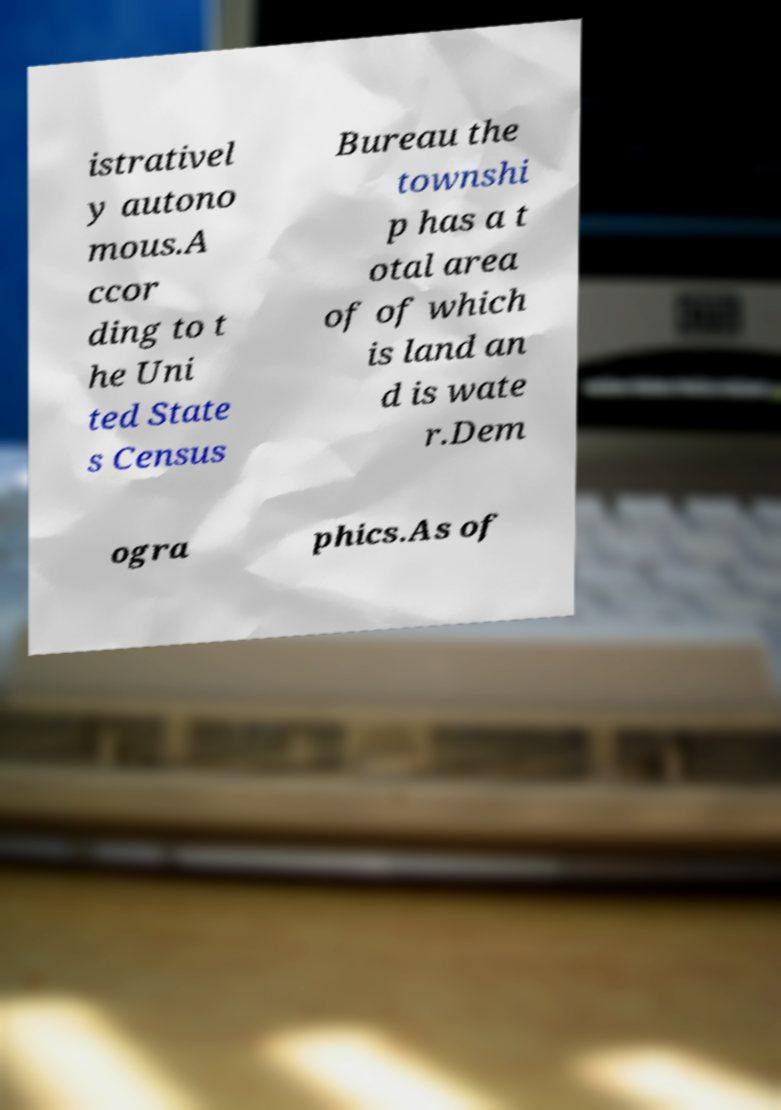There's text embedded in this image that I need extracted. Can you transcribe it verbatim? istrativel y autono mous.A ccor ding to t he Uni ted State s Census Bureau the townshi p has a t otal area of of which is land an d is wate r.Dem ogra phics.As of 